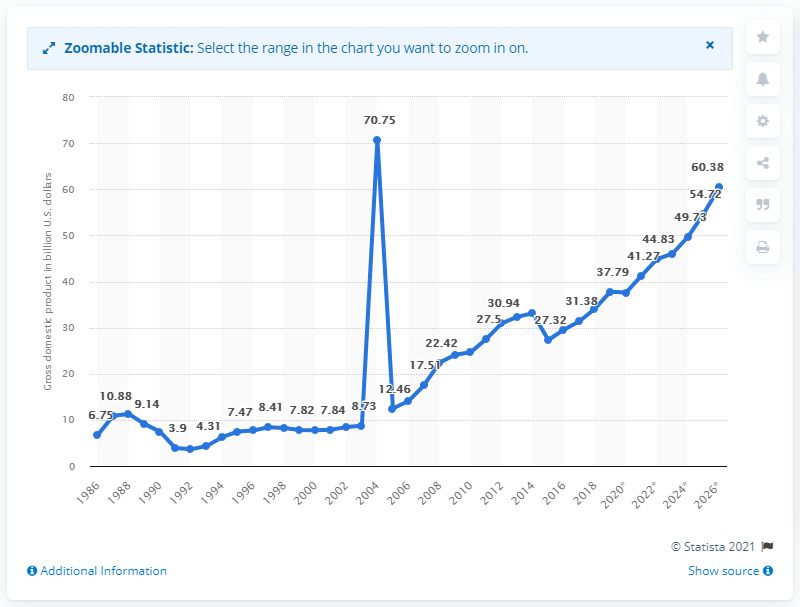Outline some significant characteristics in this image. In 2019, Uganda's gross domestic product was 37.61 billion dollars. 